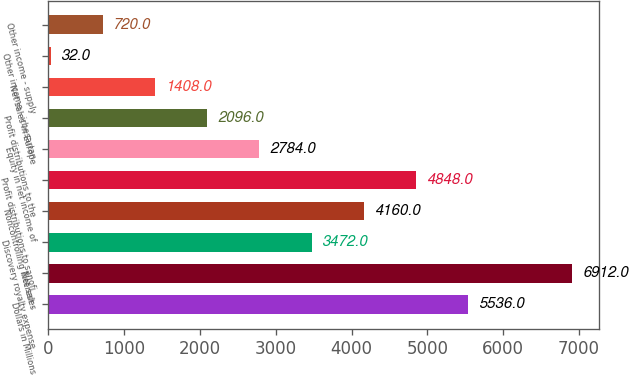<chart> <loc_0><loc_0><loc_500><loc_500><bar_chart><fcel>Dollars in Millions<fcel>Net sales<fcel>Discovery royalty expense<fcel>Noncontrolling interest -<fcel>Profit distributions to sanofi<fcel>Equity in net income of<fcel>Profit distributions to the<fcel>Net sales in Europe<fcel>Other income - irbesartan<fcel>Other income - supply<nl><fcel>5536<fcel>6912<fcel>3472<fcel>4160<fcel>4848<fcel>2784<fcel>2096<fcel>1408<fcel>32<fcel>720<nl></chart> 